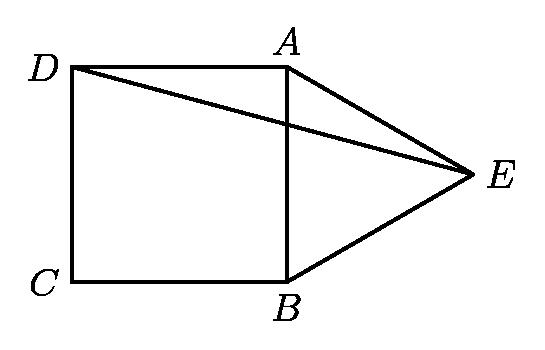Can you describe the properties of the square and the equilateral triangle in the image? The square, labeled ABCD, has all sides equal in length and all interior angles equal to 90 degrees. The equilateral triangle, labeled ABE, has all sides equal in length and all interior angles equal to 60 degrees, as properties of an equilateral triangle. 